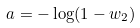<formula> <loc_0><loc_0><loc_500><loc_500>a = - \log ( 1 - w _ { 2 } )</formula> 